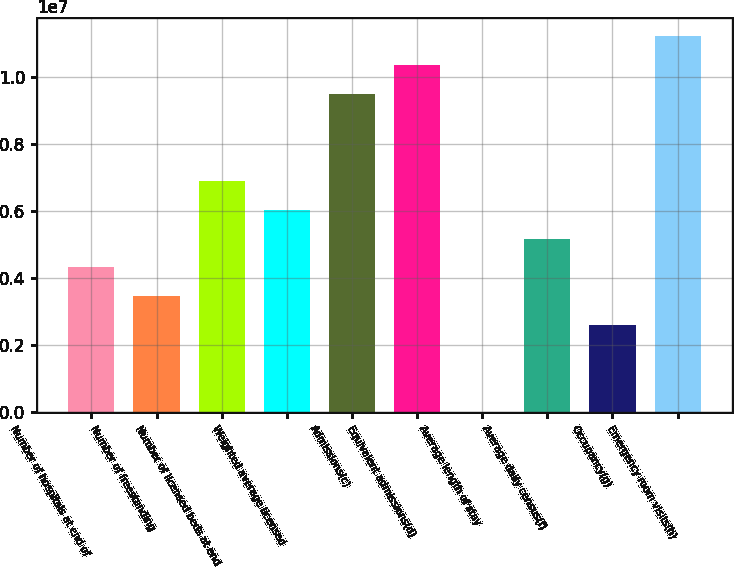Convert chart. <chart><loc_0><loc_0><loc_500><loc_500><bar_chart><fcel>Number of hospitals at end of<fcel>Number of freestanding<fcel>Number of licensed beds at end<fcel>Weighted average licensed<fcel>Admissions(c)<fcel>Equivalent admissions(d)<fcel>Average length of stay<fcel>Average daily census(f)<fcel>Occupancy(g)<fcel>Emergency room visits(h)<nl><fcel>4.31207e+06<fcel>3.44966e+06<fcel>6.89931e+06<fcel>6.0369e+06<fcel>9.48655e+06<fcel>1.0349e+07<fcel>4.9<fcel>5.17448e+06<fcel>2.58724e+06<fcel>1.12114e+07<nl></chart> 